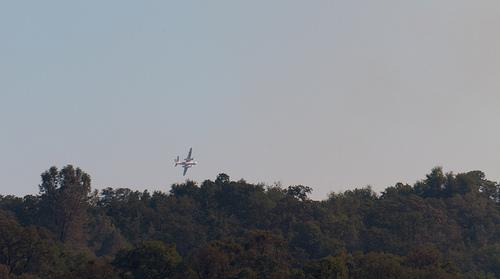Question: what color are the plants?
Choices:
A. Brown.
B. Yellow.
C. Green.
D. Tan.
Answer with the letter. Answer: C Question: what is in the air?
Choices:
A. Plane.
B. Bird.
C. Clouds.
D. Sun.
Answer with the letter. Answer: A Question: what type of scene is this?
Choices:
A. Indoor.
B. Underwater.
C. Outdoor.
D. Underground.
Answer with the letter. Answer: C 